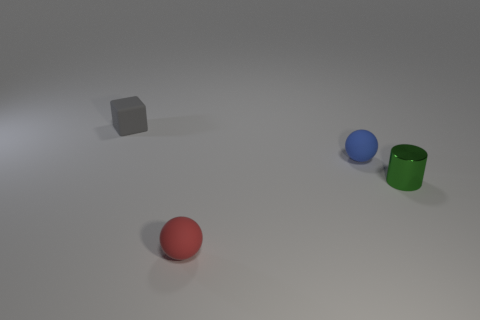Add 1 gray rubber cubes. How many objects exist? 5 Subtract all cylinders. How many objects are left? 3 Subtract 1 balls. How many balls are left? 1 Subtract all cyan cubes. Subtract all green balls. How many cubes are left? 1 Subtract all small red metal things. Subtract all blue matte spheres. How many objects are left? 3 Add 1 tiny gray rubber blocks. How many tiny gray rubber blocks are left? 2 Add 4 small gray rubber objects. How many small gray rubber objects exist? 5 Subtract 0 yellow cylinders. How many objects are left? 4 